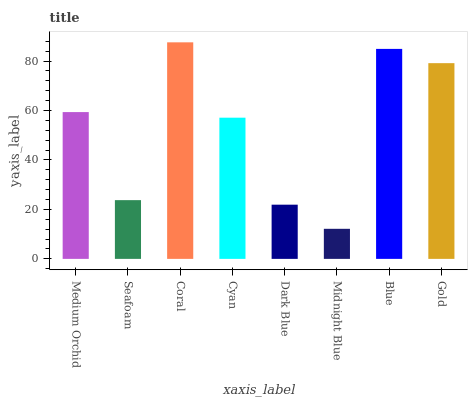Is Midnight Blue the minimum?
Answer yes or no. Yes. Is Coral the maximum?
Answer yes or no. Yes. Is Seafoam the minimum?
Answer yes or no. No. Is Seafoam the maximum?
Answer yes or no. No. Is Medium Orchid greater than Seafoam?
Answer yes or no. Yes. Is Seafoam less than Medium Orchid?
Answer yes or no. Yes. Is Seafoam greater than Medium Orchid?
Answer yes or no. No. Is Medium Orchid less than Seafoam?
Answer yes or no. No. Is Medium Orchid the high median?
Answer yes or no. Yes. Is Cyan the low median?
Answer yes or no. Yes. Is Midnight Blue the high median?
Answer yes or no. No. Is Seafoam the low median?
Answer yes or no. No. 